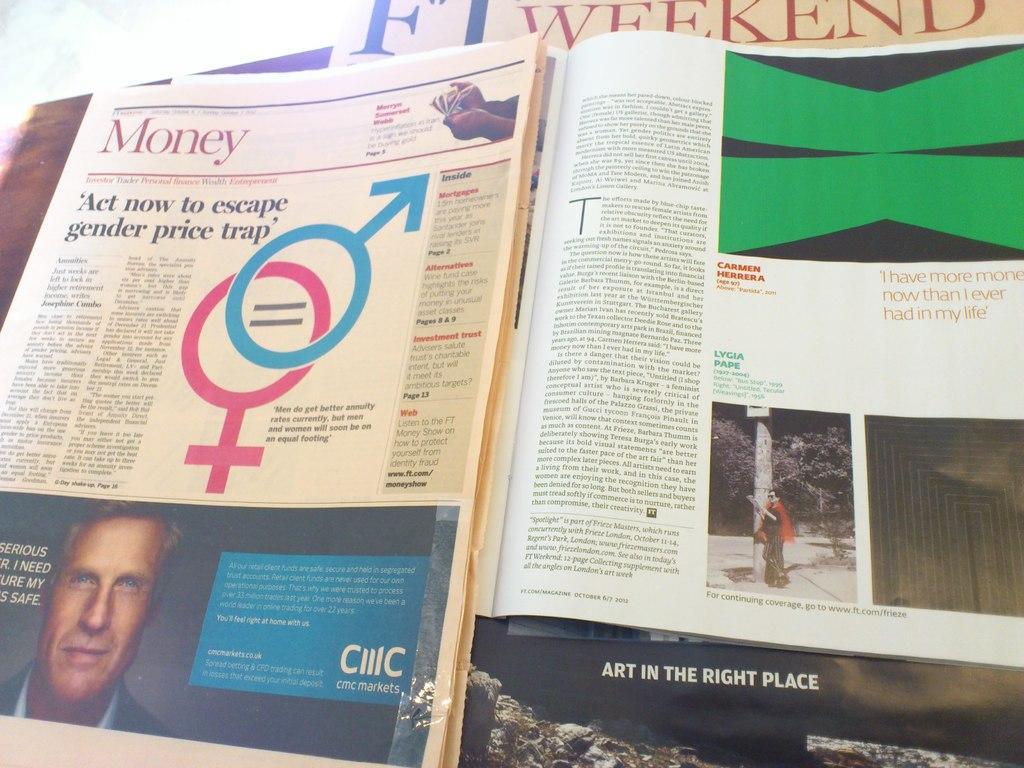Describe this image in one or two sentences. In this image, we can see a newspaper and magazine. 